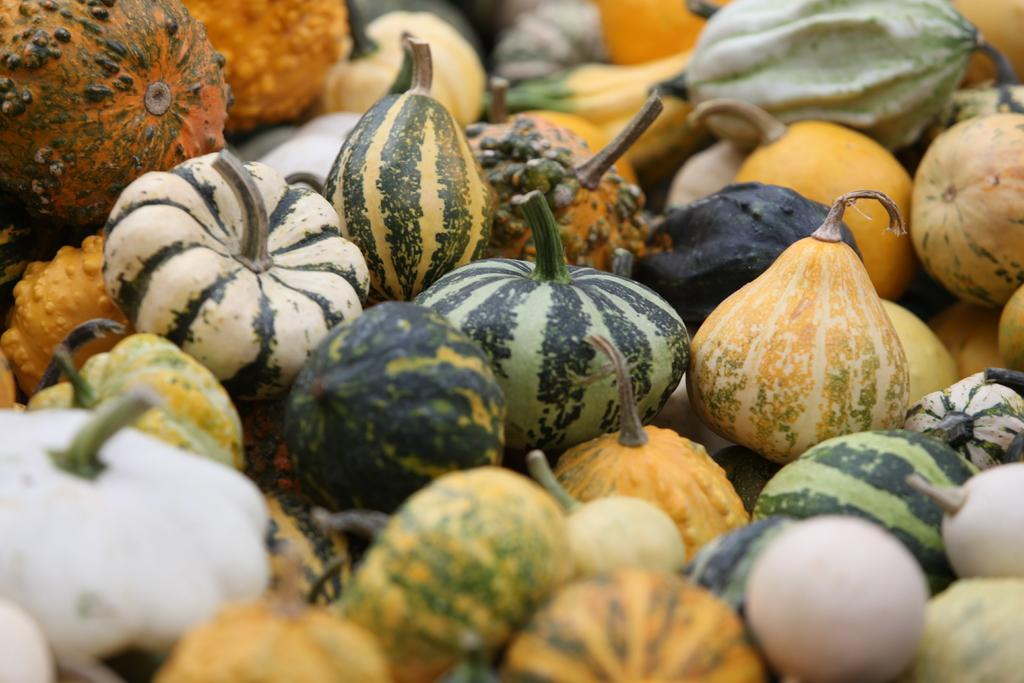What types of food can be seen in the image? There are vegetables and fruits in the image. Can you describe the variety of fruits in the image? Unfortunately, the facts provided do not specify the types of fruits or vegetables in the image. How are the vegetables and fruits arranged in the image? The facts provided do not give information about the arrangement of the vegetables and fruits in the image. What type of ticket can be seen in the image? There is no ticket present in the image; it only contains vegetables and fruits. 